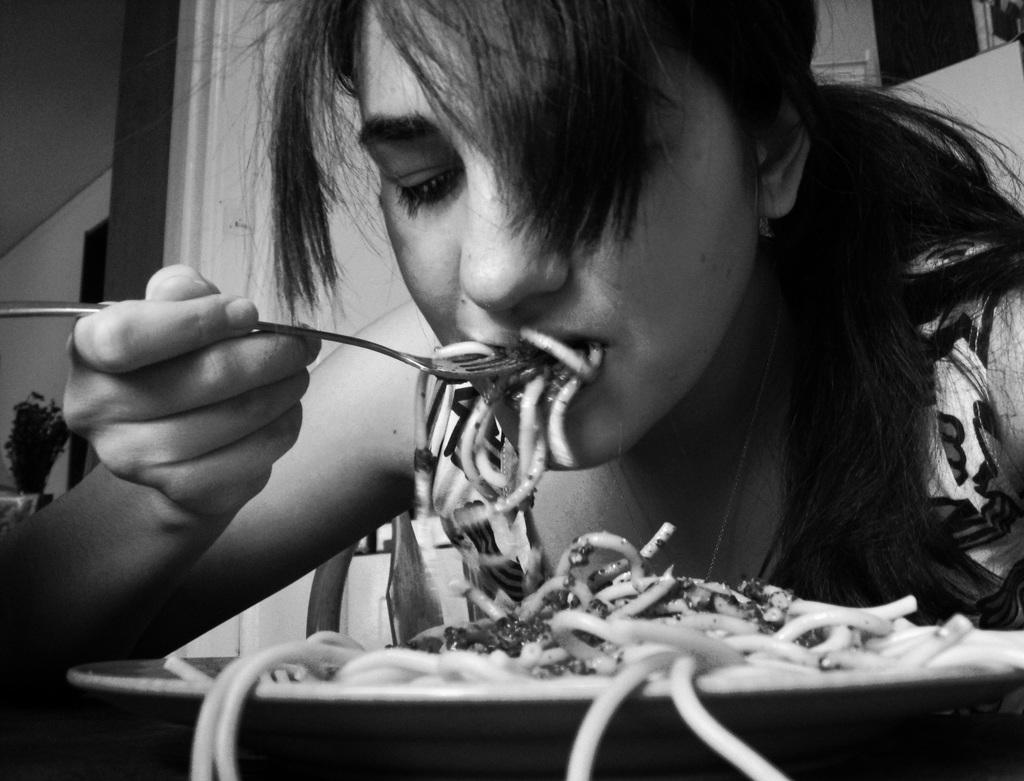What is the woman in the image doing? The woman is sitting in the image and eating an eatable item. What is the woman holding in the image? The woman is holding a spoon in the image. What can be seen on the left side of the image? There is a potted plant on the left side of the image. What type of knot is the woman trying to untie in the image? There is no knot present in the image; the woman is eating an eatable item and holding a spoon. 